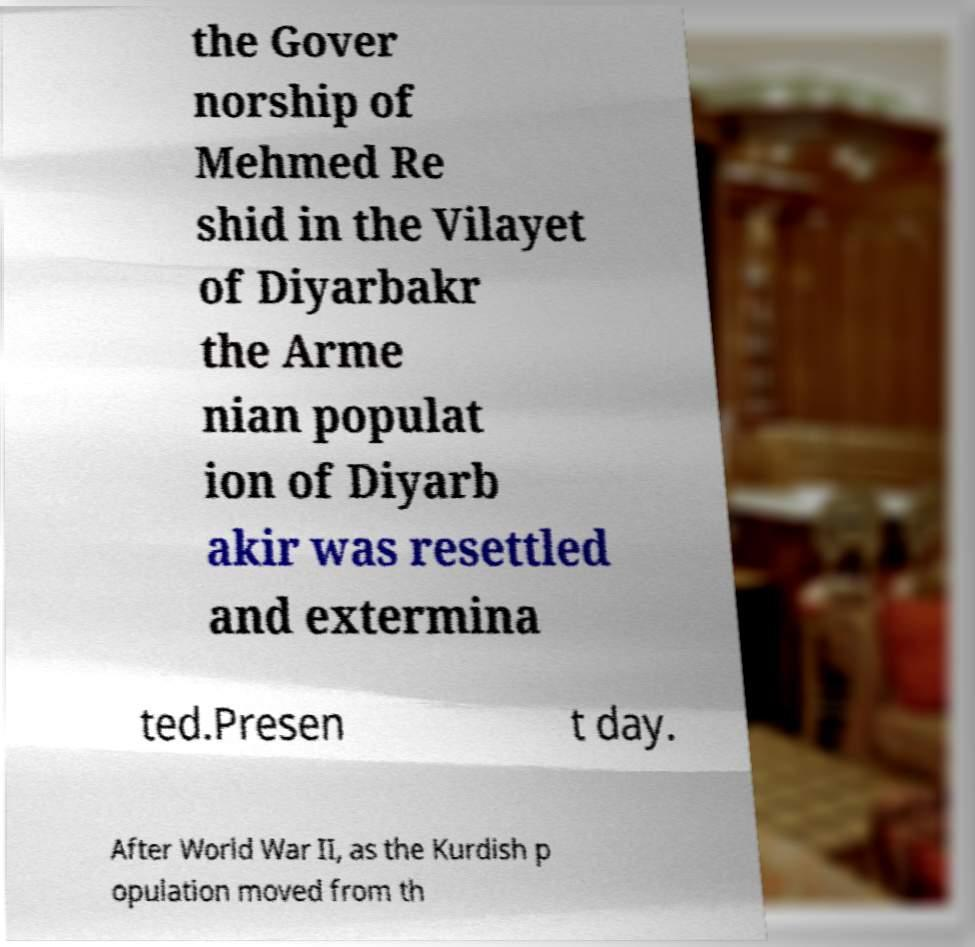What messages or text are displayed in this image? I need them in a readable, typed format. the Gover norship of Mehmed Re shid in the Vilayet of Diyarbakr the Arme nian populat ion of Diyarb akir was resettled and extermina ted.Presen t day. After World War II, as the Kurdish p opulation moved from th 